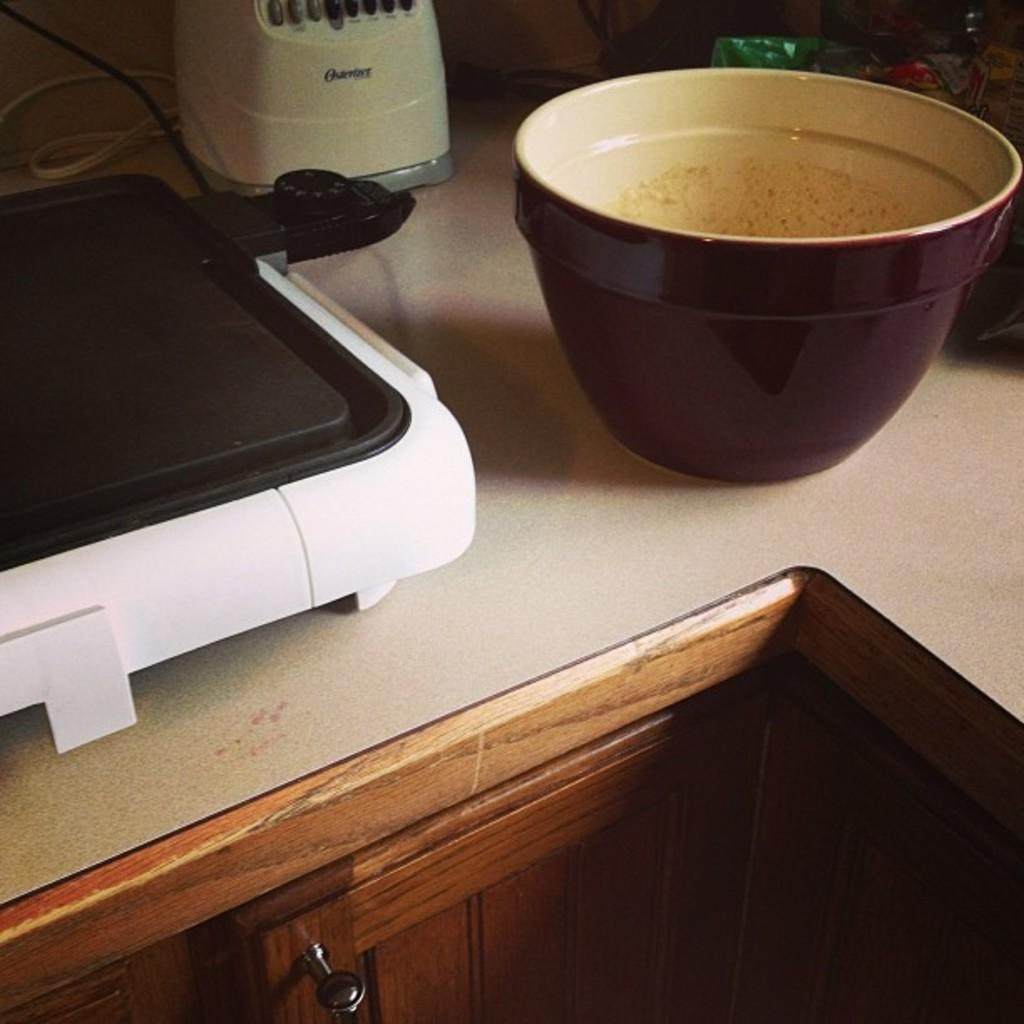<image>
Summarize the visual content of the image. An electric griddle, brown mixing bowl, and Oyster blender sitting on a kitchen counter. 